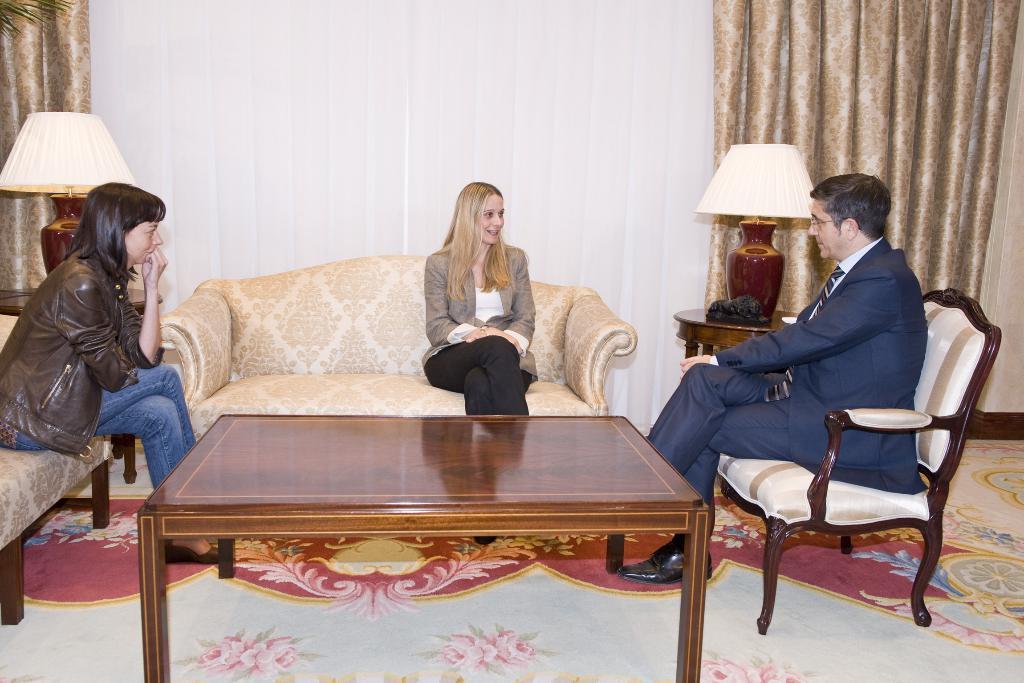Can you describe this image briefly? There are three persons sitting on the sofa. This is table. There are lamps. On the background there is a wall and this is curtain. And this is floor. 